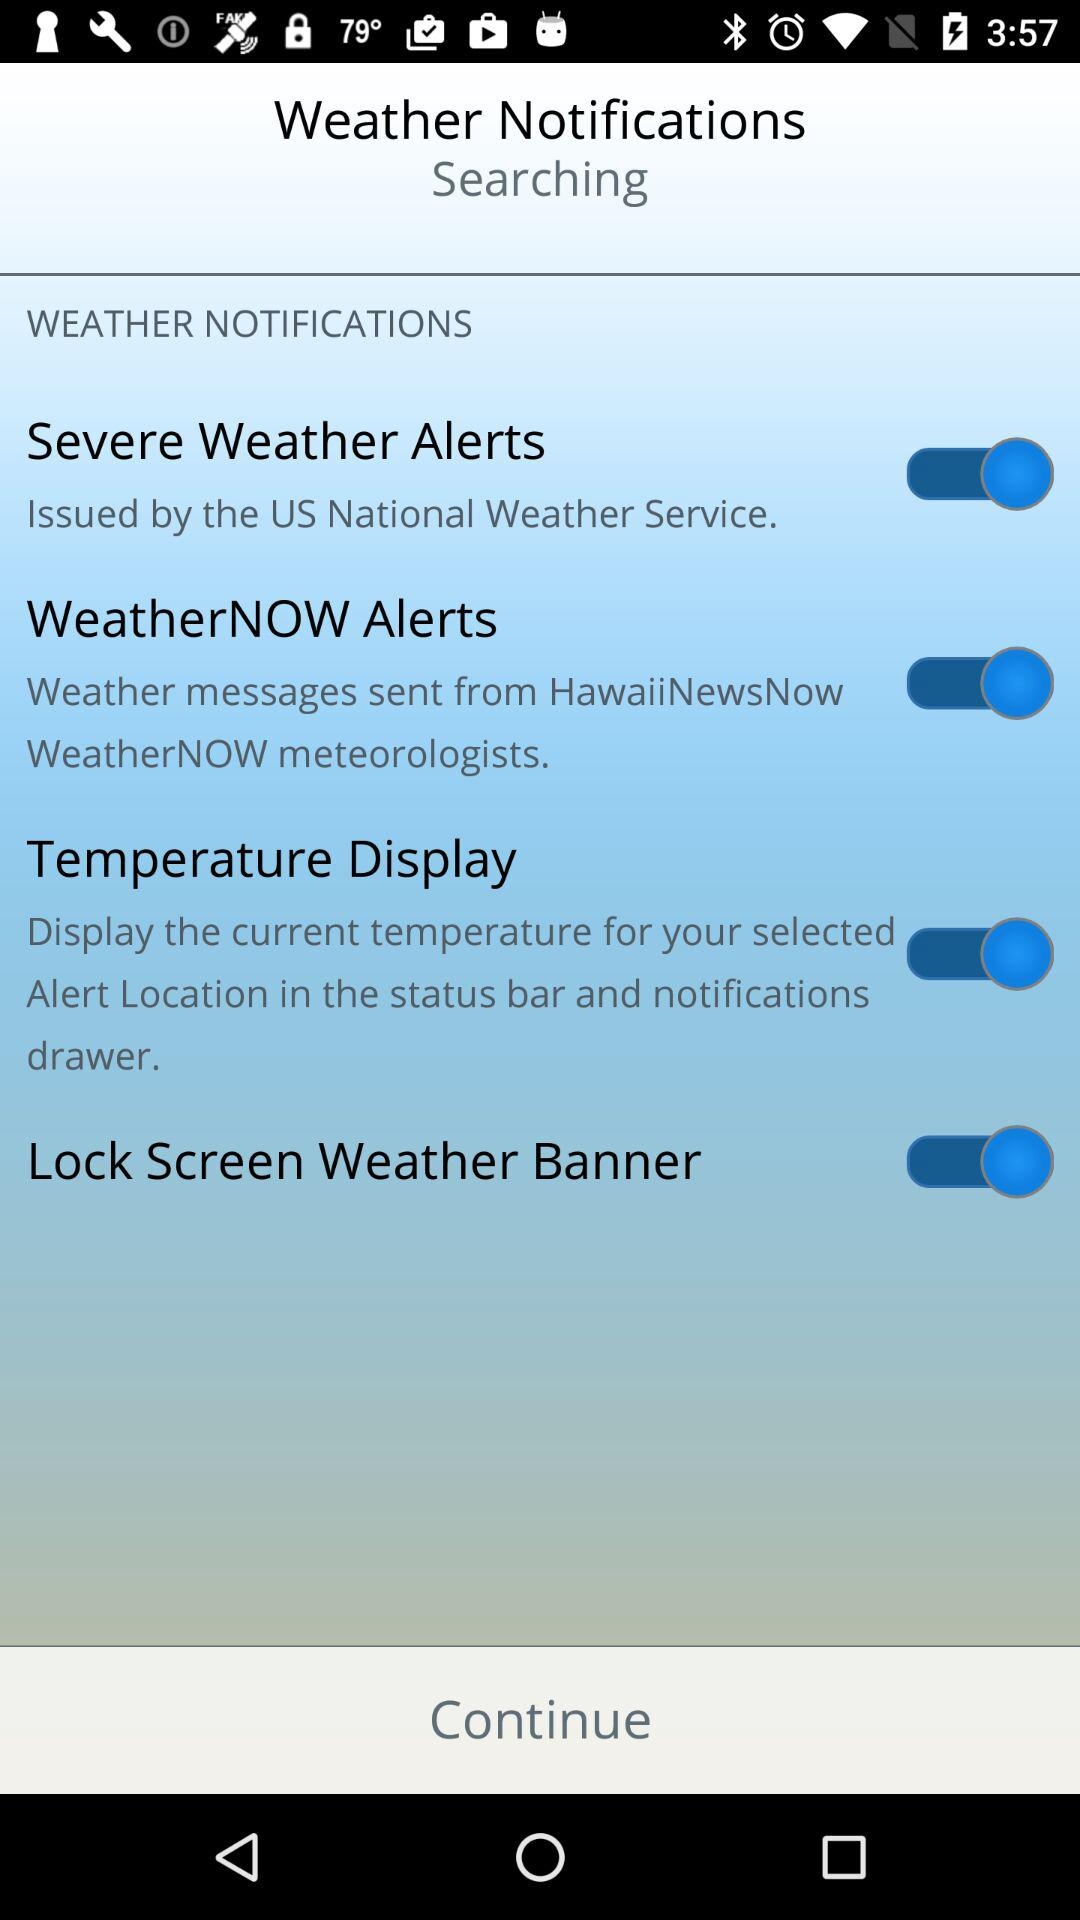What is the status of the "Temperature Display"? The status of the "Temperature Display" is "on". 